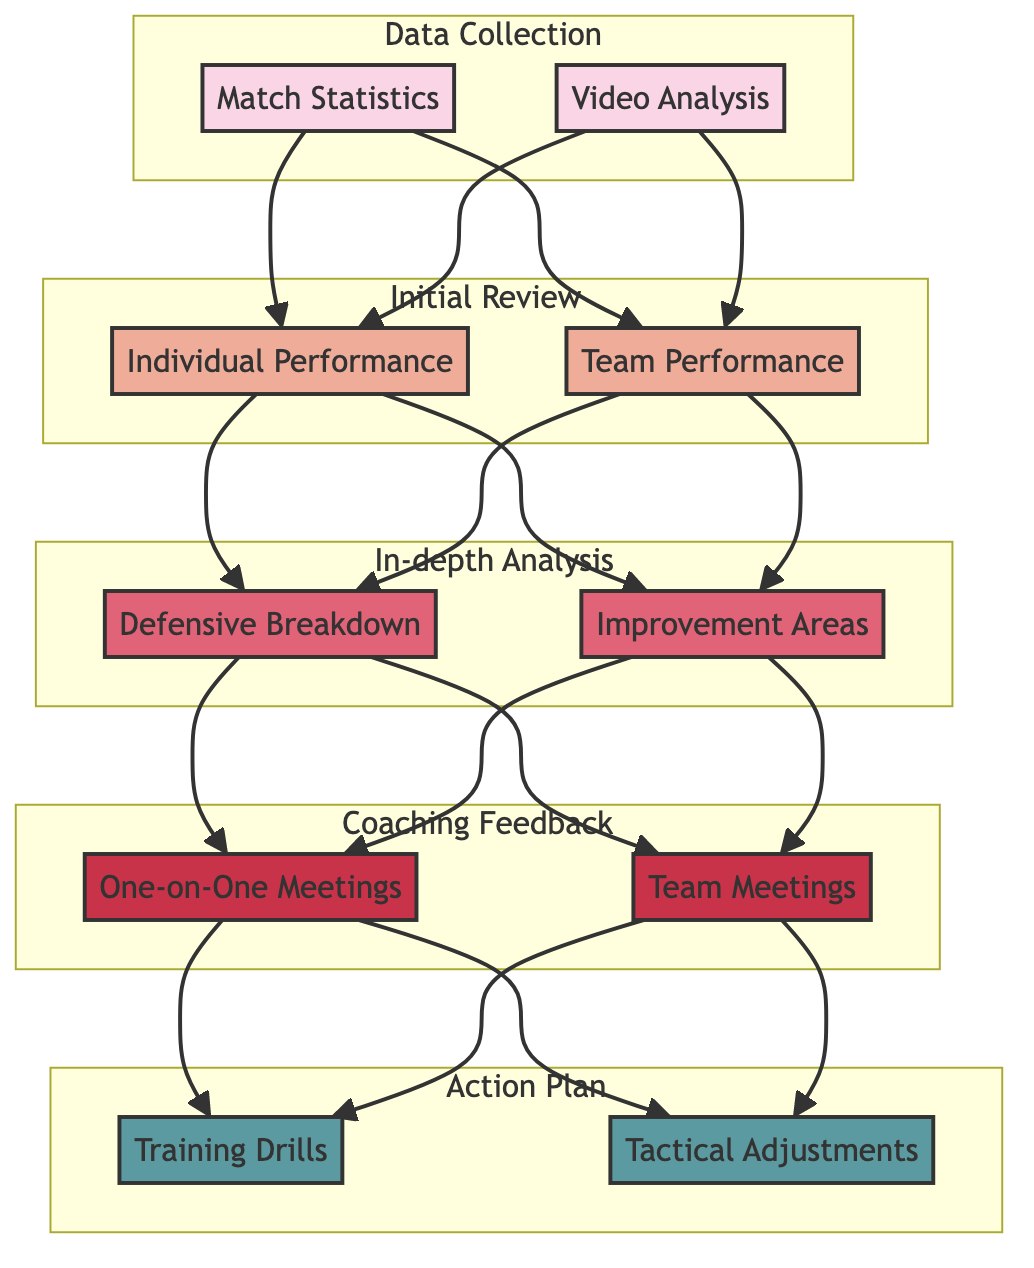What are the elements in Level 1? The elements in Level 1, which focuses on Data Collection, are Match Statistics and Video Analysis. They constitute the initial step of the post-match analysis process.
Answer: Match Statistics, Video Analysis How many sub-elements are there in Level 2? In Level 2, there are two sub-elements: Individual Performance and Team Performance. This indicates a focus on both player-specific and team-wide evaluations.
Answer: 2 What follows the In-depth Analysis? After the In-depth Analysis, which consists of Defensive Breakdown and Improvement Areas, the next step is Coaching Feedback, aiming to provide insights based on the analytical results.
Answer: Coaching Feedback Which elements contribute to Team Performance? The Team Performance element is specifically influenced by data collected from Match Statistics and Video Analysis, which contribute to understanding collective team dynamics during the match.
Answer: Match Statistics, Video Analysis What type of meetings occur in Level 4? In Level 4, the meetings conducted are one-on-one meetings and team meetings, focusing on targeted feedback and broader team strategies, respectively.
Answer: One-on-One Meetings, Team Meetings What is the relationship between Defensive Breakdown and Training Drills? Defensive Breakdown leads to the creation of an Action Plan that includes Training Drills, indicating that insights gained from analyzing the defense's performance aim to improve tactical execution through practice.
Answer: Action Plan How many total elements are there across all levels? There are a total of ten elements across all levels: two in Level 1, two in Level 2, two in Level 3, two in Level 4, and two in Level 5, showing a consistent structure throughout the analysis process.
Answer: 10 What are the two focus areas in the Action Plan? The Action Plan focuses on Training Drills and Tactical Adjustments, which are both essential for implementing the strategies derived from the analysis and feedback processes.
Answer: Training Drills, Tactical Adjustments 